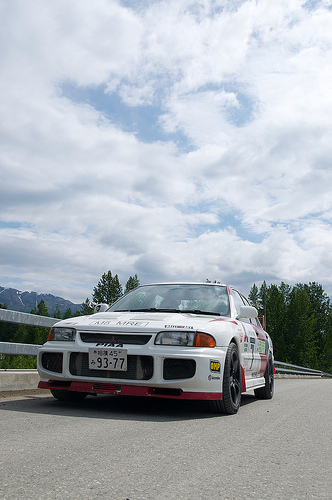<image>
Is there a clouds above the trees? Yes. The clouds is positioned above the trees in the vertical space, higher up in the scene. Is the car above the road? No. The car is not positioned above the road. The vertical arrangement shows a different relationship. 